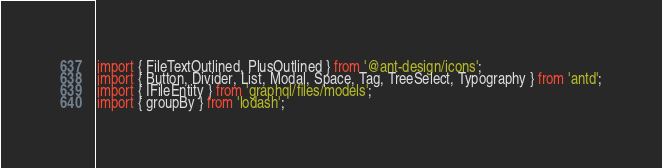Convert code to text. <code><loc_0><loc_0><loc_500><loc_500><_TypeScript_>import { FileTextOutlined, PlusOutlined } from '@ant-design/icons';
import { Button, Divider, List, Modal, Space, Tag, TreeSelect, Typography } from 'antd';
import { IFileEntity } from 'graphql/files/models';
import { groupBy } from 'lodash';</code> 